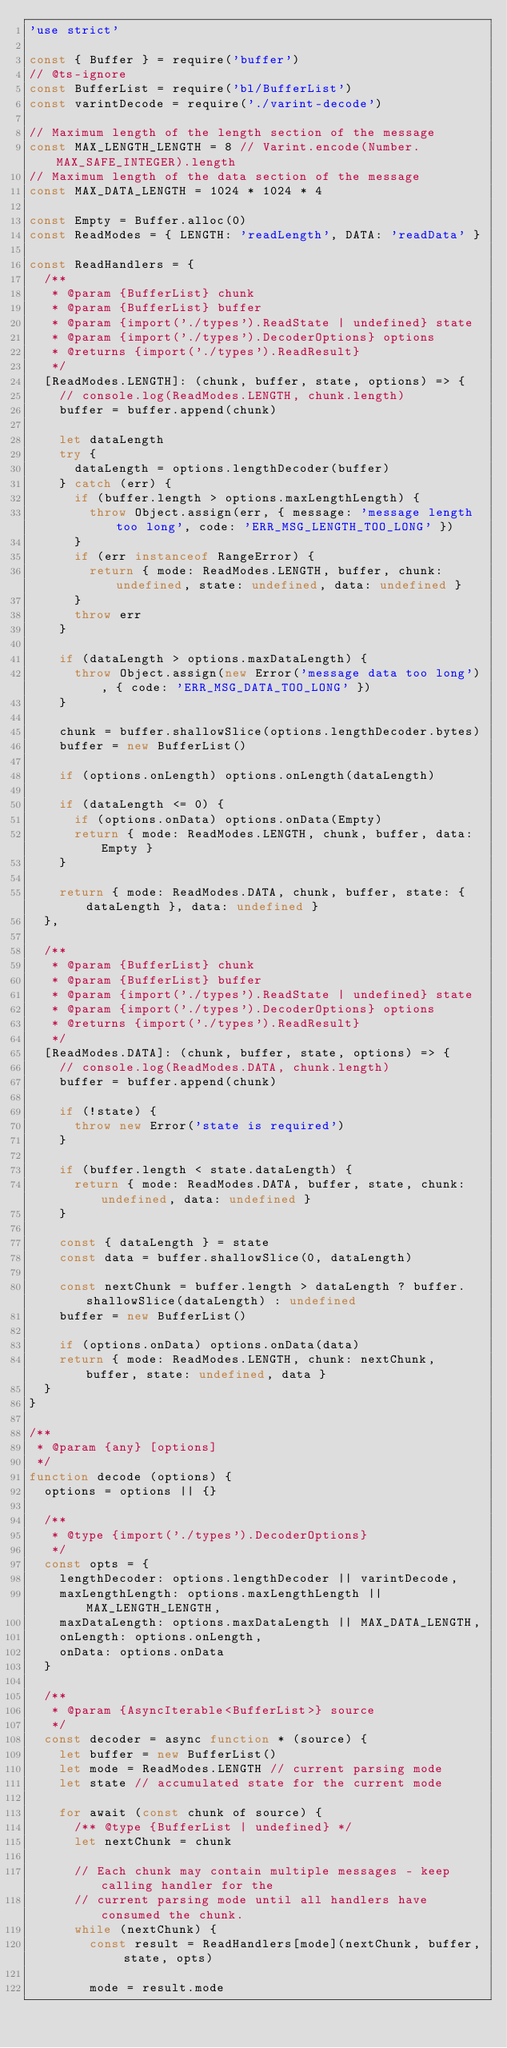<code> <loc_0><loc_0><loc_500><loc_500><_JavaScript_>'use strict'

const { Buffer } = require('buffer')
// @ts-ignore
const BufferList = require('bl/BufferList')
const varintDecode = require('./varint-decode')

// Maximum length of the length section of the message
const MAX_LENGTH_LENGTH = 8 // Varint.encode(Number.MAX_SAFE_INTEGER).length
// Maximum length of the data section of the message
const MAX_DATA_LENGTH = 1024 * 1024 * 4

const Empty = Buffer.alloc(0)
const ReadModes = { LENGTH: 'readLength', DATA: 'readData' }

const ReadHandlers = {
  /**
   * @param {BufferList} chunk
   * @param {BufferList} buffer
   * @param {import('./types').ReadState | undefined} state
   * @param {import('./types').DecoderOptions} options
   * @returns {import('./types').ReadResult}
   */
  [ReadModes.LENGTH]: (chunk, buffer, state, options) => {
    // console.log(ReadModes.LENGTH, chunk.length)
    buffer = buffer.append(chunk)

    let dataLength
    try {
      dataLength = options.lengthDecoder(buffer)
    } catch (err) {
      if (buffer.length > options.maxLengthLength) {
        throw Object.assign(err, { message: 'message length too long', code: 'ERR_MSG_LENGTH_TOO_LONG' })
      }
      if (err instanceof RangeError) {
        return { mode: ReadModes.LENGTH, buffer, chunk: undefined, state: undefined, data: undefined }
      }
      throw err
    }

    if (dataLength > options.maxDataLength) {
      throw Object.assign(new Error('message data too long'), { code: 'ERR_MSG_DATA_TOO_LONG' })
    }

    chunk = buffer.shallowSlice(options.lengthDecoder.bytes)
    buffer = new BufferList()

    if (options.onLength) options.onLength(dataLength)

    if (dataLength <= 0) {
      if (options.onData) options.onData(Empty)
      return { mode: ReadModes.LENGTH, chunk, buffer, data: Empty }
    }

    return { mode: ReadModes.DATA, chunk, buffer, state: { dataLength }, data: undefined }
  },

  /**
   * @param {BufferList} chunk
   * @param {BufferList} buffer
   * @param {import('./types').ReadState | undefined} state
   * @param {import('./types').DecoderOptions} options
   * @returns {import('./types').ReadResult}
   */
  [ReadModes.DATA]: (chunk, buffer, state, options) => {
    // console.log(ReadModes.DATA, chunk.length)
    buffer = buffer.append(chunk)

    if (!state) {
      throw new Error('state is required')
    }

    if (buffer.length < state.dataLength) {
      return { mode: ReadModes.DATA, buffer, state, chunk: undefined, data: undefined }
    }

    const { dataLength } = state
    const data = buffer.shallowSlice(0, dataLength)

    const nextChunk = buffer.length > dataLength ? buffer.shallowSlice(dataLength) : undefined
    buffer = new BufferList()

    if (options.onData) options.onData(data)
    return { mode: ReadModes.LENGTH, chunk: nextChunk, buffer, state: undefined, data }
  }
}

/**
 * @param {any} [options]
 */
function decode (options) {
  options = options || {}

  /**
   * @type {import('./types').DecoderOptions}
   */
  const opts = {
    lengthDecoder: options.lengthDecoder || varintDecode,
    maxLengthLength: options.maxLengthLength || MAX_LENGTH_LENGTH,
    maxDataLength: options.maxDataLength || MAX_DATA_LENGTH,
    onLength: options.onLength,
    onData: options.onData
  }

  /**
   * @param {AsyncIterable<BufferList>} source
   */
  const decoder = async function * (source) {
    let buffer = new BufferList()
    let mode = ReadModes.LENGTH // current parsing mode
    let state // accumulated state for the current mode

    for await (const chunk of source) {
      /** @type {BufferList | undefined} */
      let nextChunk = chunk

      // Each chunk may contain multiple messages - keep calling handler for the
      // current parsing mode until all handlers have consumed the chunk.
      while (nextChunk) {
        const result = ReadHandlers[mode](nextChunk, buffer, state, opts)

        mode = result.mode</code> 